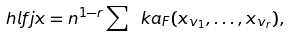Convert formula to latex. <formula><loc_0><loc_0><loc_500><loc_500>\ h l f j x = n ^ { 1 - r } \sum \ k a _ { F } ( x _ { v _ { 1 } } , \dots , x _ { v _ { r } } ) ,</formula> 